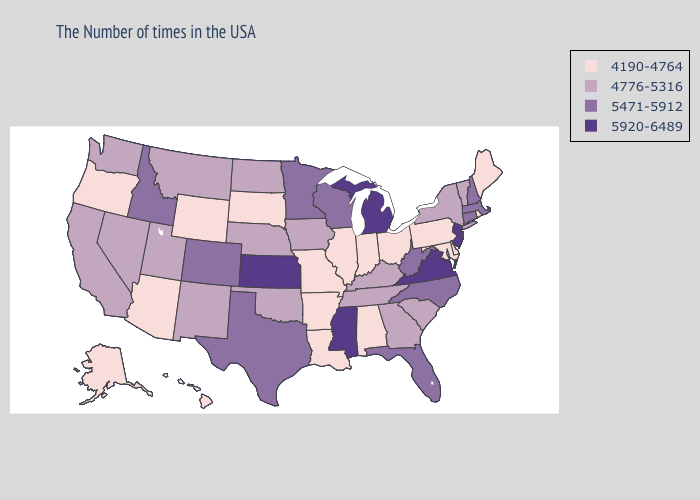Name the states that have a value in the range 5920-6489?
Answer briefly. New Jersey, Virginia, Michigan, Mississippi, Kansas. What is the lowest value in states that border Kentucky?
Concise answer only. 4190-4764. Which states have the highest value in the USA?
Give a very brief answer. New Jersey, Virginia, Michigan, Mississippi, Kansas. What is the highest value in states that border California?
Quick response, please. 4776-5316. Name the states that have a value in the range 5920-6489?
Write a very short answer. New Jersey, Virginia, Michigan, Mississippi, Kansas. What is the highest value in the USA?
Keep it brief. 5920-6489. Name the states that have a value in the range 5471-5912?
Answer briefly. Massachusetts, New Hampshire, Connecticut, North Carolina, West Virginia, Florida, Wisconsin, Minnesota, Texas, Colorado, Idaho. Does Vermont have a higher value than Minnesota?
Quick response, please. No. Name the states that have a value in the range 4190-4764?
Concise answer only. Maine, Rhode Island, Delaware, Maryland, Pennsylvania, Ohio, Indiana, Alabama, Illinois, Louisiana, Missouri, Arkansas, South Dakota, Wyoming, Arizona, Oregon, Alaska, Hawaii. How many symbols are there in the legend?
Write a very short answer. 4. Among the states that border Colorado , does Kansas have the highest value?
Concise answer only. Yes. What is the lowest value in the West?
Give a very brief answer. 4190-4764. Which states have the highest value in the USA?
Concise answer only. New Jersey, Virginia, Michigan, Mississippi, Kansas. Does New York have the lowest value in the USA?
Quick response, please. No. Name the states that have a value in the range 4776-5316?
Keep it brief. Vermont, New York, South Carolina, Georgia, Kentucky, Tennessee, Iowa, Nebraska, Oklahoma, North Dakota, New Mexico, Utah, Montana, Nevada, California, Washington. 